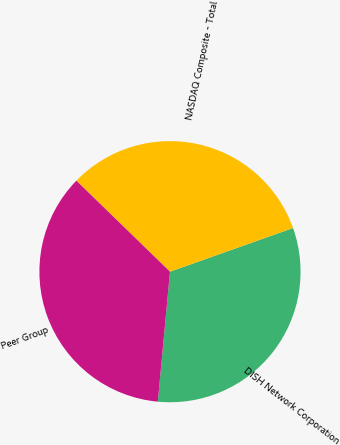Convert chart. <chart><loc_0><loc_0><loc_500><loc_500><pie_chart><fcel>DISH Network Corporation<fcel>NASDAQ Composite - Total<fcel>Peer Group<nl><fcel>31.91%<fcel>32.3%<fcel>35.79%<nl></chart> 